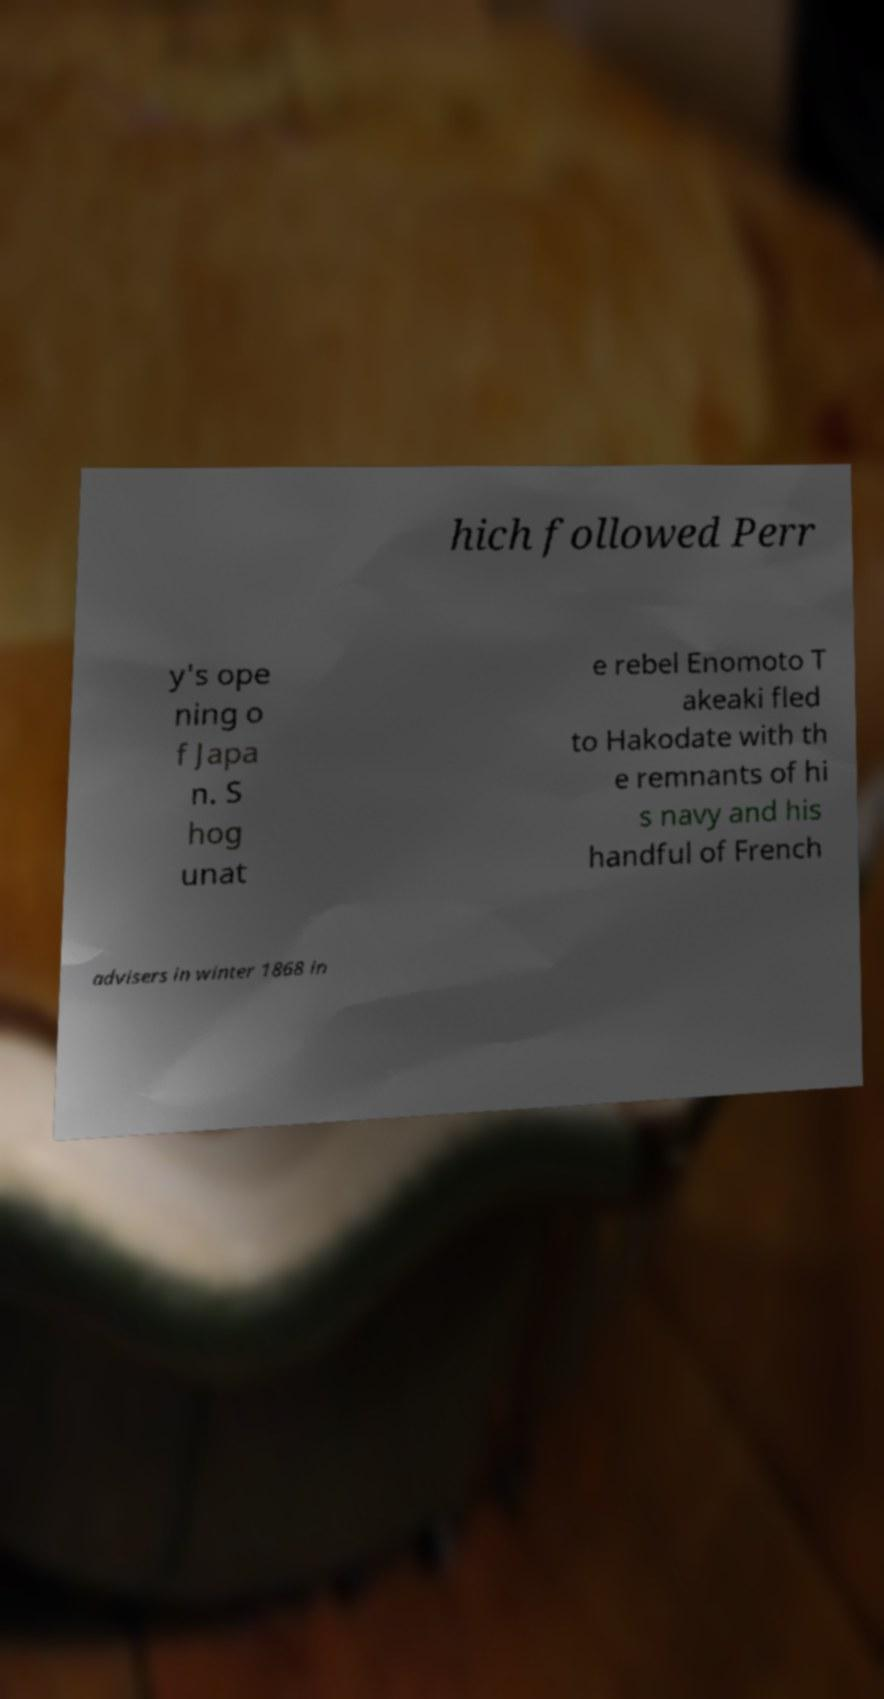I need the written content from this picture converted into text. Can you do that? hich followed Perr y's ope ning o f Japa n. S hog unat e rebel Enomoto T akeaki fled to Hakodate with th e remnants of hi s navy and his handful of French advisers in winter 1868 in 